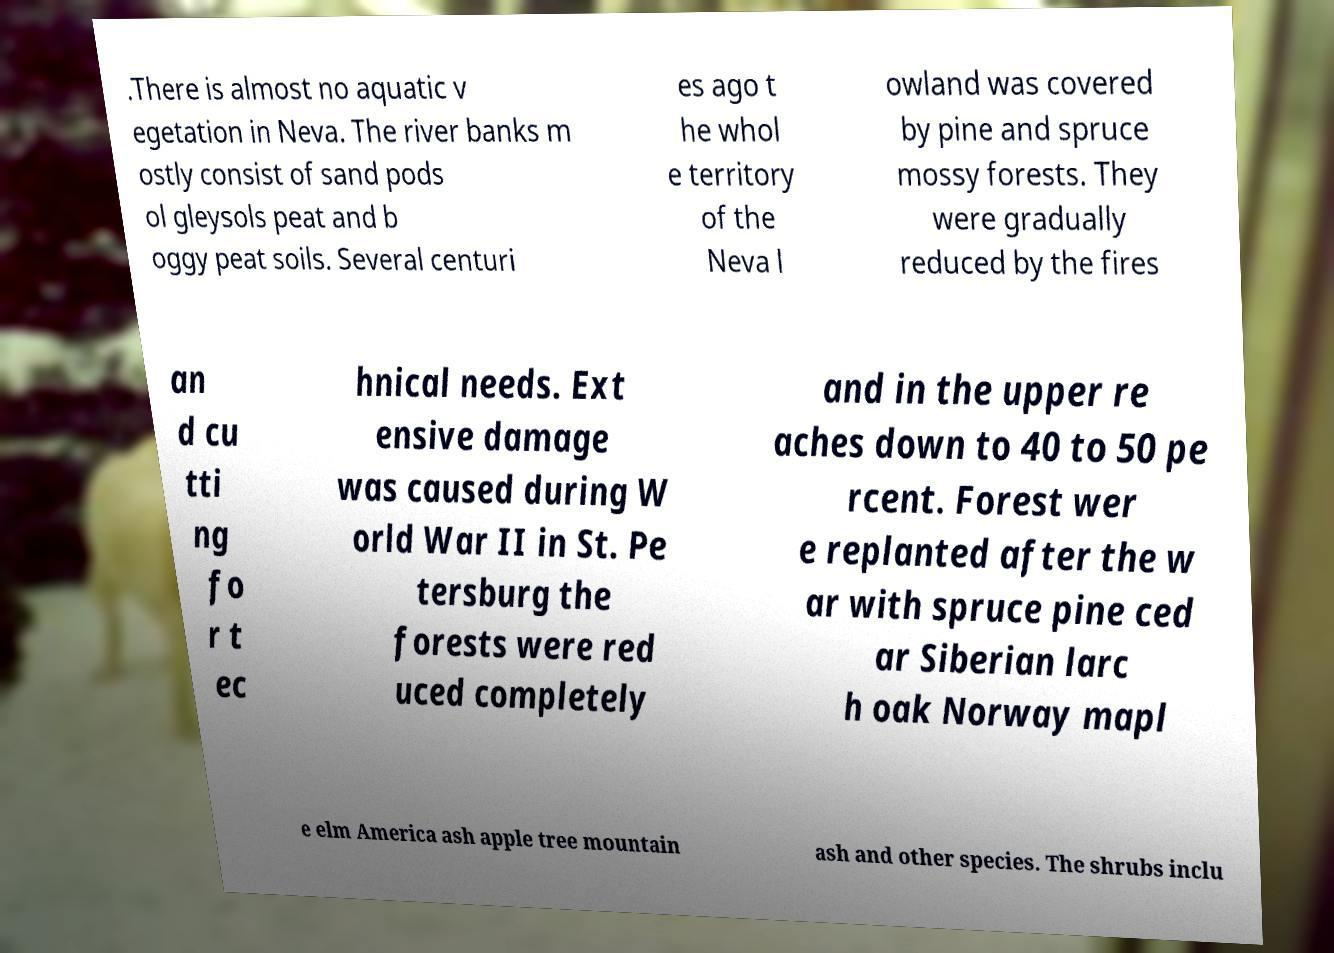Please identify and transcribe the text found in this image. .There is almost no aquatic v egetation in Neva. The river banks m ostly consist of sand pods ol gleysols peat and b oggy peat soils. Several centuri es ago t he whol e territory of the Neva l owland was covered by pine and spruce mossy forests. They were gradually reduced by the fires an d cu tti ng fo r t ec hnical needs. Ext ensive damage was caused during W orld War II in St. Pe tersburg the forests were red uced completely and in the upper re aches down to 40 to 50 pe rcent. Forest wer e replanted after the w ar with spruce pine ced ar Siberian larc h oak Norway mapl e elm America ash apple tree mountain ash and other species. The shrubs inclu 